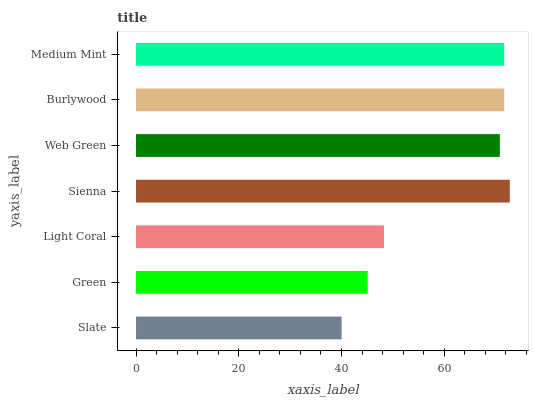Is Slate the minimum?
Answer yes or no. Yes. Is Sienna the maximum?
Answer yes or no. Yes. Is Green the minimum?
Answer yes or no. No. Is Green the maximum?
Answer yes or no. No. Is Green greater than Slate?
Answer yes or no. Yes. Is Slate less than Green?
Answer yes or no. Yes. Is Slate greater than Green?
Answer yes or no. No. Is Green less than Slate?
Answer yes or no. No. Is Web Green the high median?
Answer yes or no. Yes. Is Web Green the low median?
Answer yes or no. Yes. Is Green the high median?
Answer yes or no. No. Is Slate the low median?
Answer yes or no. No. 